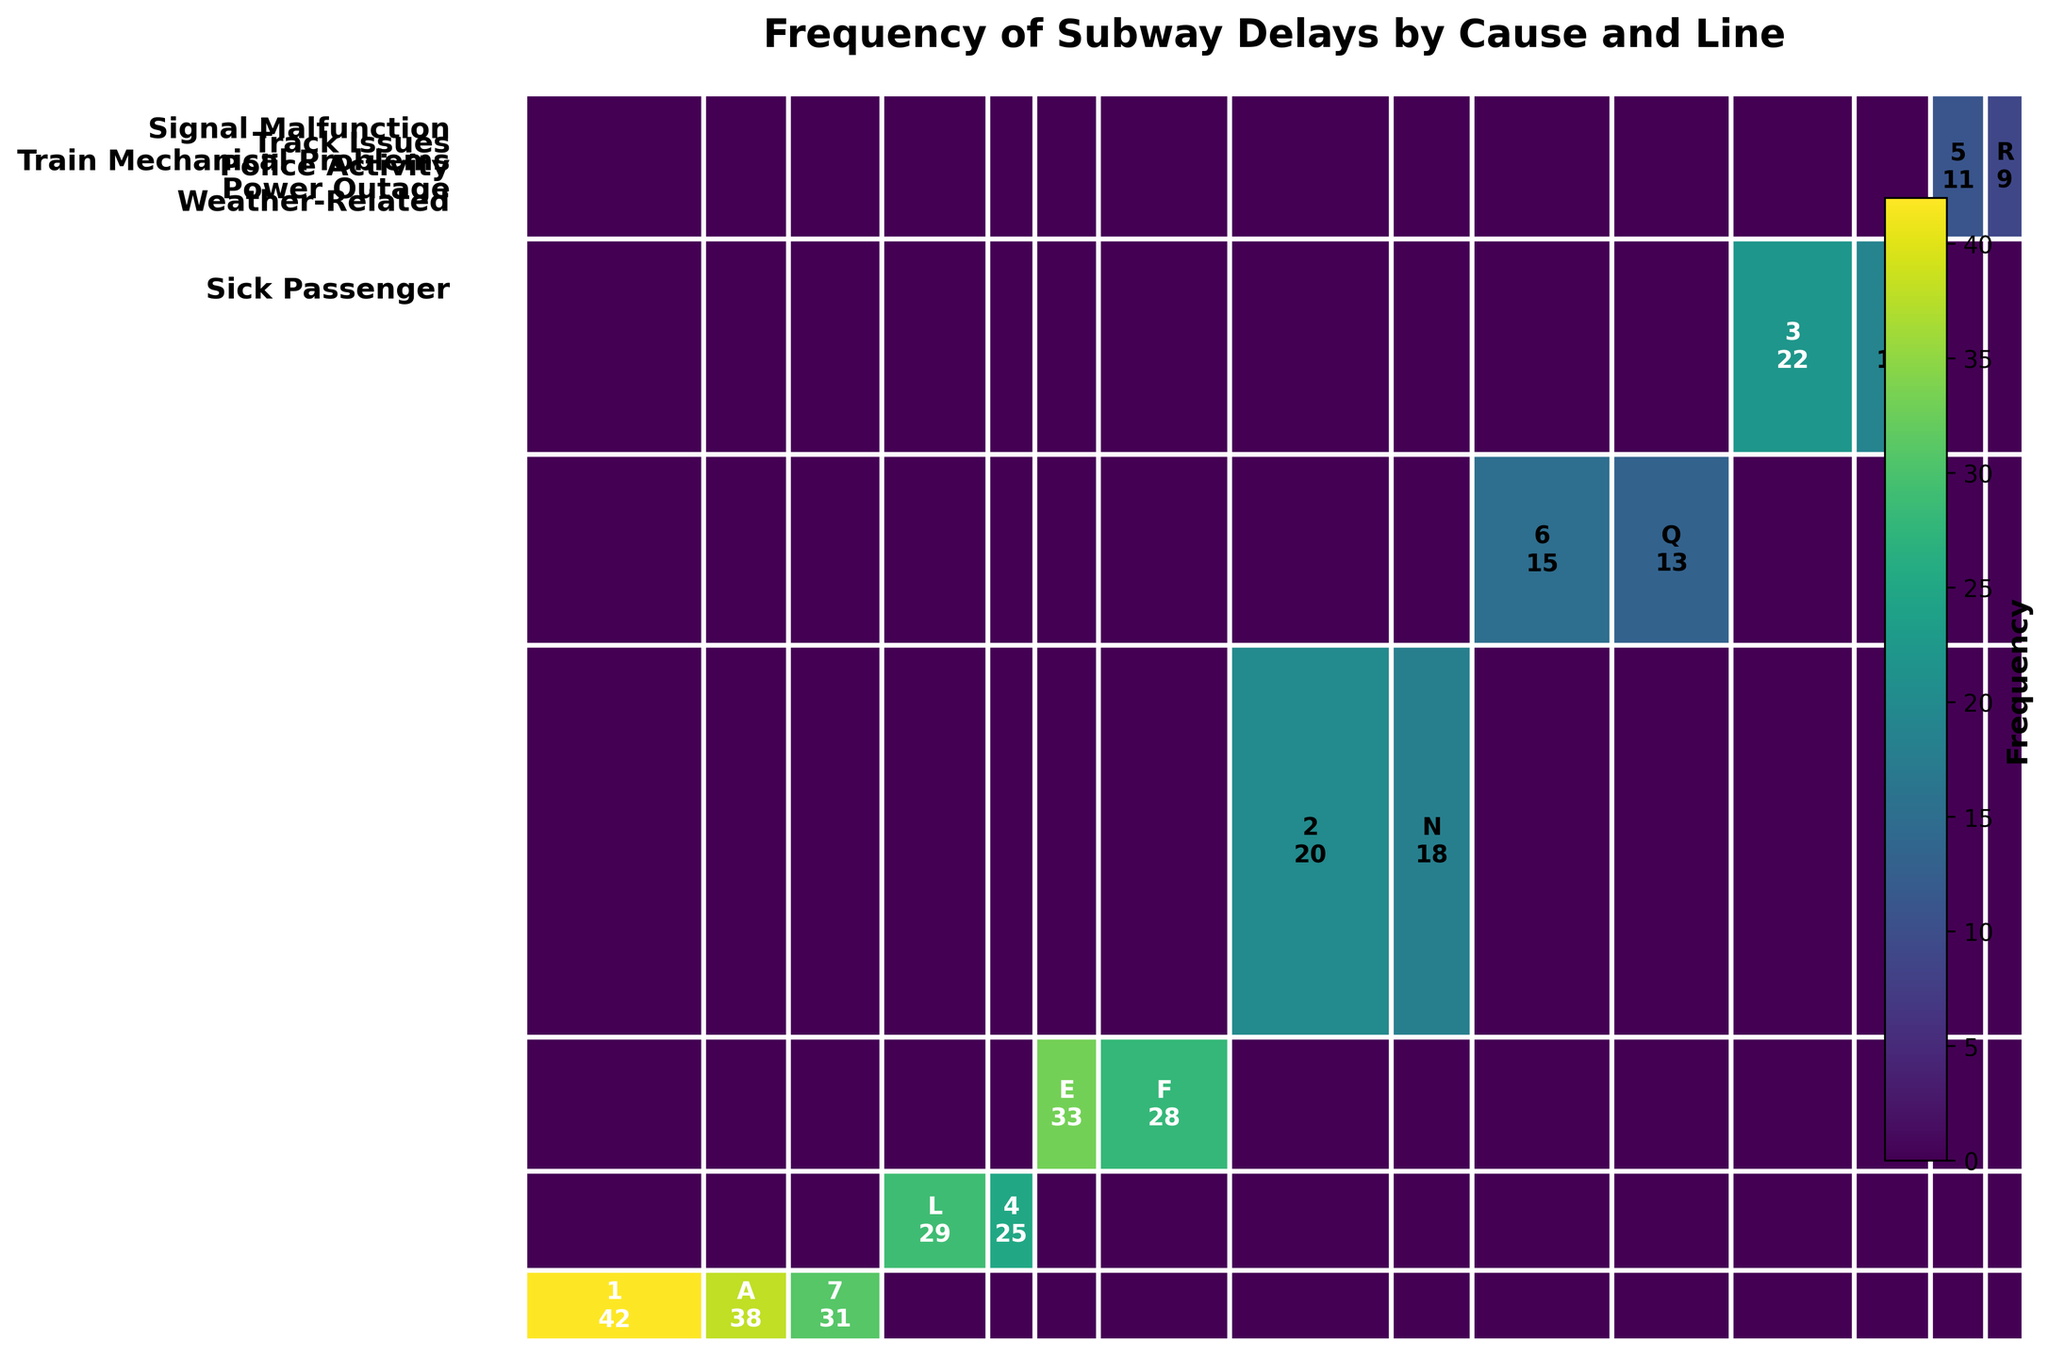which line shows the highest frequency of delays caused by 'Signal Malfunction'? Referring to the plot under 'Signal Malfunction', the line with the largest area would indicate the highest frequency. Visual inspection shows line 1 has the largest area.
Answer: 1 which cause has the lowest number of delays? In the figure, the smallest area represents the lowest number of delays. ‘Police Activity’ has the smallest area.
Answer: Police Activity compare the total delays caused by 'Track Issues' with 'Train Mechanical Problems'. Which one is greater? Summing the frequencies for 'Track Issues' and 'Train Mechanical Problems', and comparing them shows 'Track Issues' (29 + 25 = 54) is less than 'Train Mechanical Problems' (33 + 28 = 61).
Answer: Train Mechanical Problems what are the unique causes of delays according to the plot? Observing the vertical axis labels in the plot, the unique causes listed are ‘Signal Malfunction’, ‘Track Issues’, ‘Train Mechanical Problems’, ‘Sick Passenger’, ‘Power Outage’, ‘Weather-Related’, and ‘Police Activity’.
Answer: Signal Malfunction, Track Issues, Train Mechanical Problems, Sick Passenger, Power Outage, Weather-Related, Police Activity which line experiences the highest and lowest total number of delays overall? Summing the delays across all causes for each line and comparing shows that Line 1 has the highest total delay frequency while Line R has the lowest.
Answer: Highest: 1, Lowest: R 